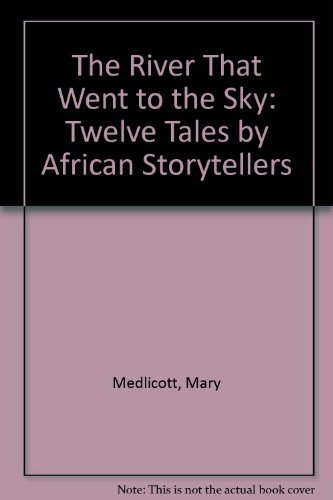What is the genre of this book? This book falls under the genre of Children's Books, providing engaging and imaginative stories aimed at young readers. 